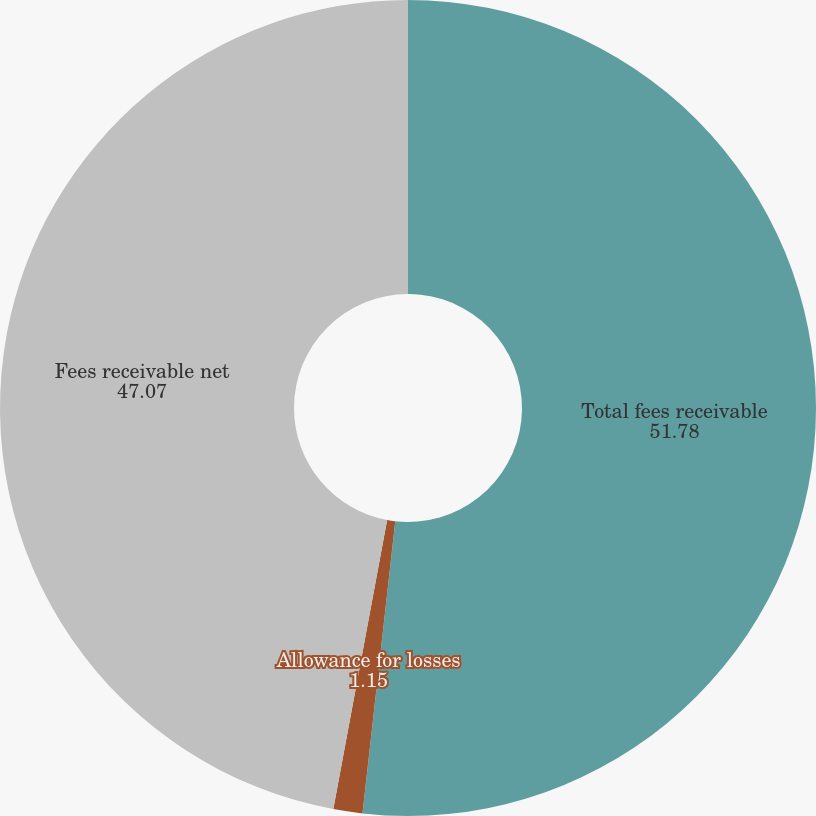Convert chart. <chart><loc_0><loc_0><loc_500><loc_500><pie_chart><fcel>Total fees receivable<fcel>Allowance for losses<fcel>Fees receivable net<nl><fcel>51.78%<fcel>1.15%<fcel>47.07%<nl></chart> 